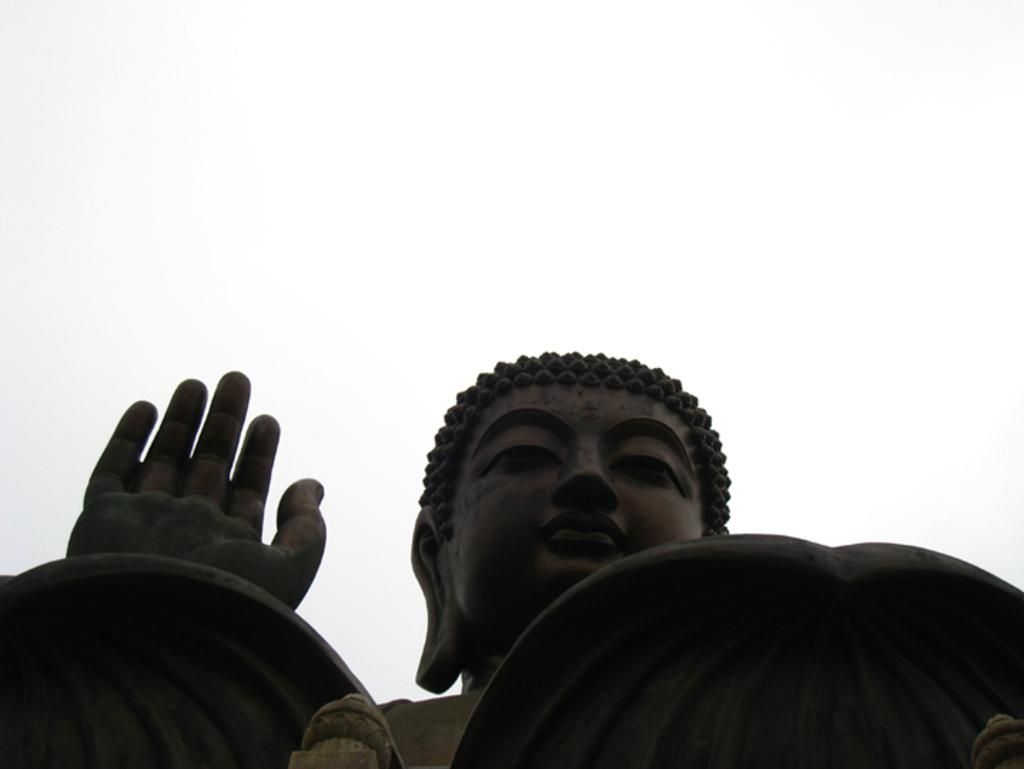What is the main subject of the picture? The main subject of the picture is a statue of Buddha. What can be seen in the background of the picture? The sky is visible at the top of the picture. What type of teeth can be seen on the statue of Buddha in the image? There are no teeth visible on the statue of Buddha in the image, as statues typically do not have teeth. 